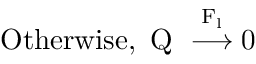Convert formula to latex. <formula><loc_0><loc_0><loc_500><loc_500>O t h e r w i s e , Q \stackrel { F _ { l } } { \longrightarrow } 0</formula> 